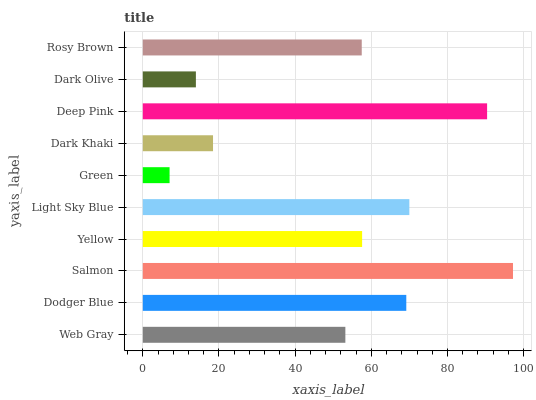Is Green the minimum?
Answer yes or no. Yes. Is Salmon the maximum?
Answer yes or no. Yes. Is Dodger Blue the minimum?
Answer yes or no. No. Is Dodger Blue the maximum?
Answer yes or no. No. Is Dodger Blue greater than Web Gray?
Answer yes or no. Yes. Is Web Gray less than Dodger Blue?
Answer yes or no. Yes. Is Web Gray greater than Dodger Blue?
Answer yes or no. No. Is Dodger Blue less than Web Gray?
Answer yes or no. No. Is Yellow the high median?
Answer yes or no. Yes. Is Rosy Brown the low median?
Answer yes or no. Yes. Is Deep Pink the high median?
Answer yes or no. No. Is Yellow the low median?
Answer yes or no. No. 